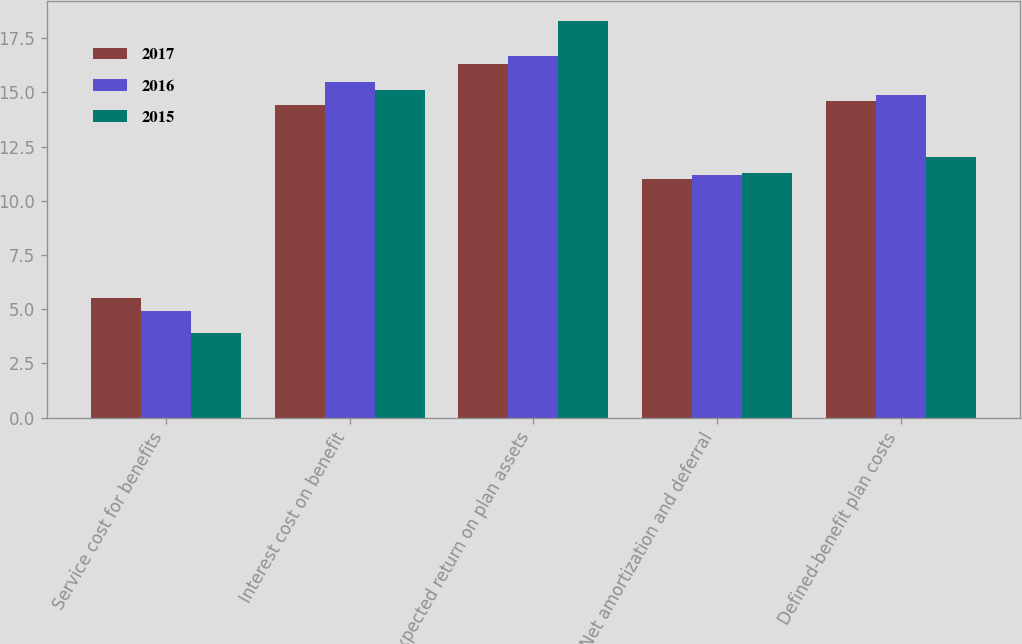Convert chart to OTSL. <chart><loc_0><loc_0><loc_500><loc_500><stacked_bar_chart><ecel><fcel>Service cost for benefits<fcel>Interest cost on benefit<fcel>Expected return on plan assets<fcel>Net amortization and deferral<fcel>Defined-benefit plan costs<nl><fcel>2017<fcel>5.5<fcel>14.4<fcel>16.3<fcel>11<fcel>14.6<nl><fcel>2016<fcel>4.9<fcel>15.5<fcel>16.7<fcel>11.2<fcel>14.9<nl><fcel>2015<fcel>3.9<fcel>15.1<fcel>18.3<fcel>11.3<fcel>12<nl></chart> 